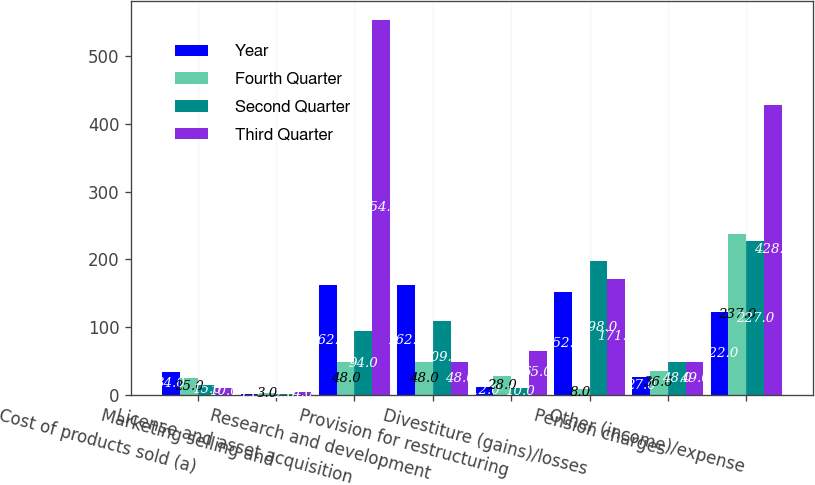Convert chart. <chart><loc_0><loc_0><loc_500><loc_500><stacked_bar_chart><ecel><fcel>Cost of products sold (a)<fcel>Marketing selling and<fcel>License and asset acquisition<fcel>Research and development<fcel>Provision for restructuring<fcel>Divestiture (gains)/losses<fcel>Pension charges<fcel>Other (income)/expense<nl><fcel>Year<fcel>34<fcel>1<fcel>162<fcel>162<fcel>12<fcel>152<fcel>27<fcel>122<nl><fcel>Fourth Quarter<fcel>25<fcel>3<fcel>48<fcel>48<fcel>28<fcel>8<fcel>36<fcel>237<nl><fcel>Second Quarter<fcel>15<fcel>2<fcel>94<fcel>109<fcel>10<fcel>198<fcel>48<fcel>227<nl><fcel>Third Quarter<fcel>10<fcel>4<fcel>554<fcel>48<fcel>65<fcel>171<fcel>49<fcel>428<nl></chart> 